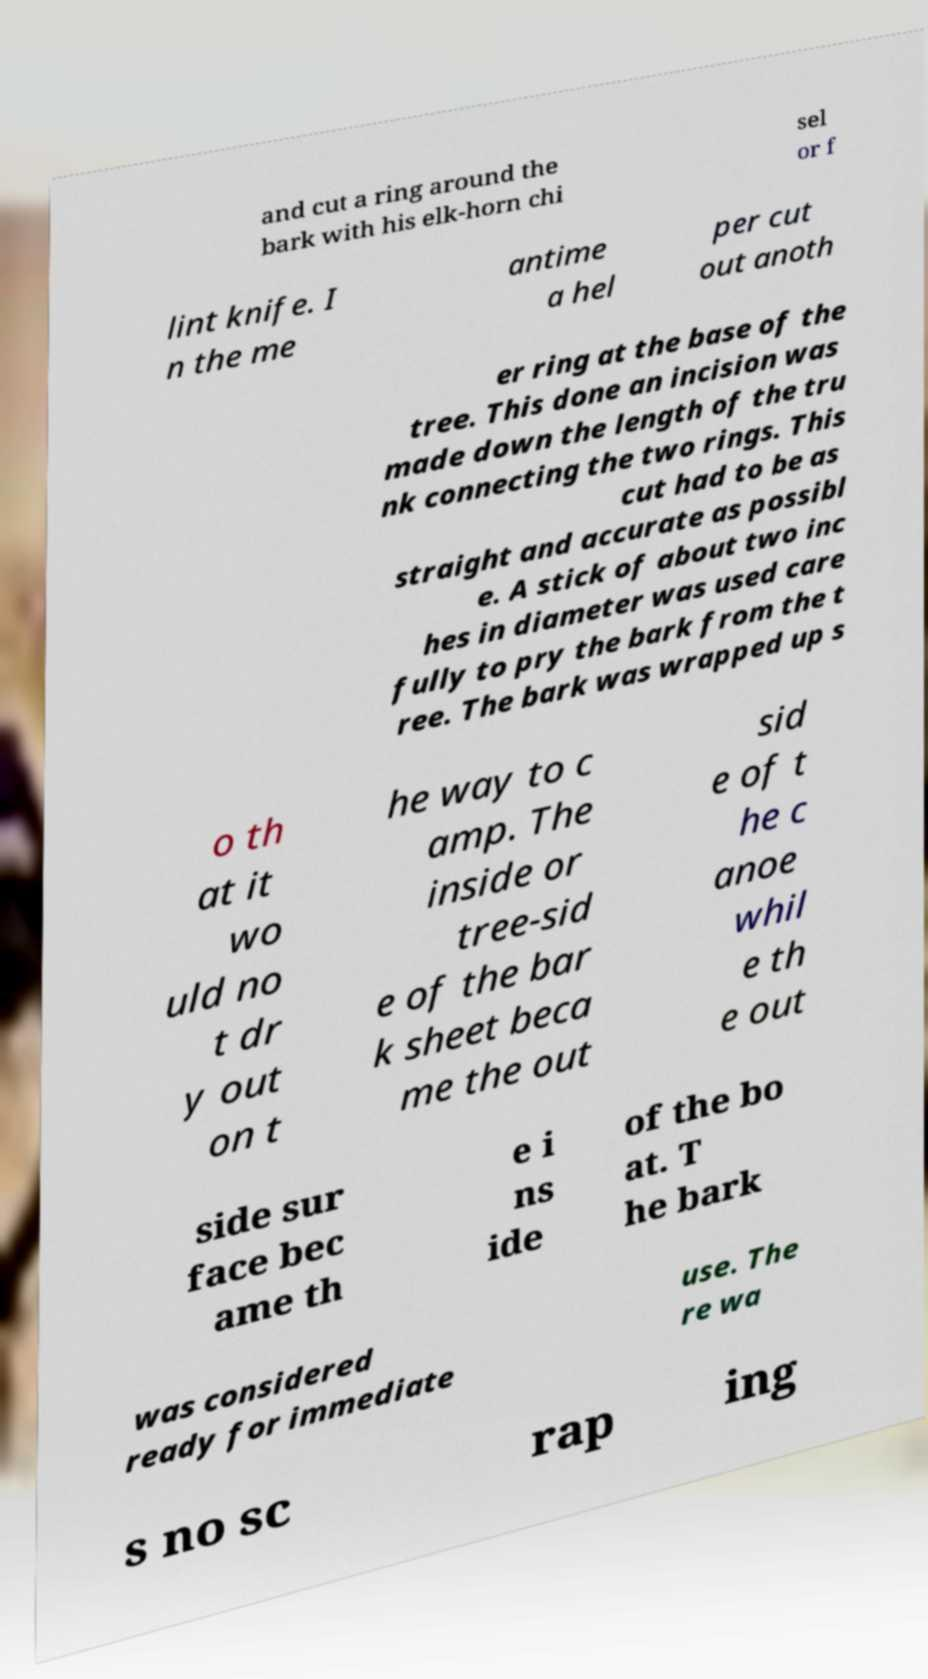I need the written content from this picture converted into text. Can you do that? and cut a ring around the bark with his elk-horn chi sel or f lint knife. I n the me antime a hel per cut out anoth er ring at the base of the tree. This done an incision was made down the length of the tru nk connecting the two rings. This cut had to be as straight and accurate as possibl e. A stick of about two inc hes in diameter was used care fully to pry the bark from the t ree. The bark was wrapped up s o th at it wo uld no t dr y out on t he way to c amp. The inside or tree-sid e of the bar k sheet beca me the out sid e of t he c anoe whil e th e out side sur face bec ame th e i ns ide of the bo at. T he bark was considered ready for immediate use. The re wa s no sc rap ing 